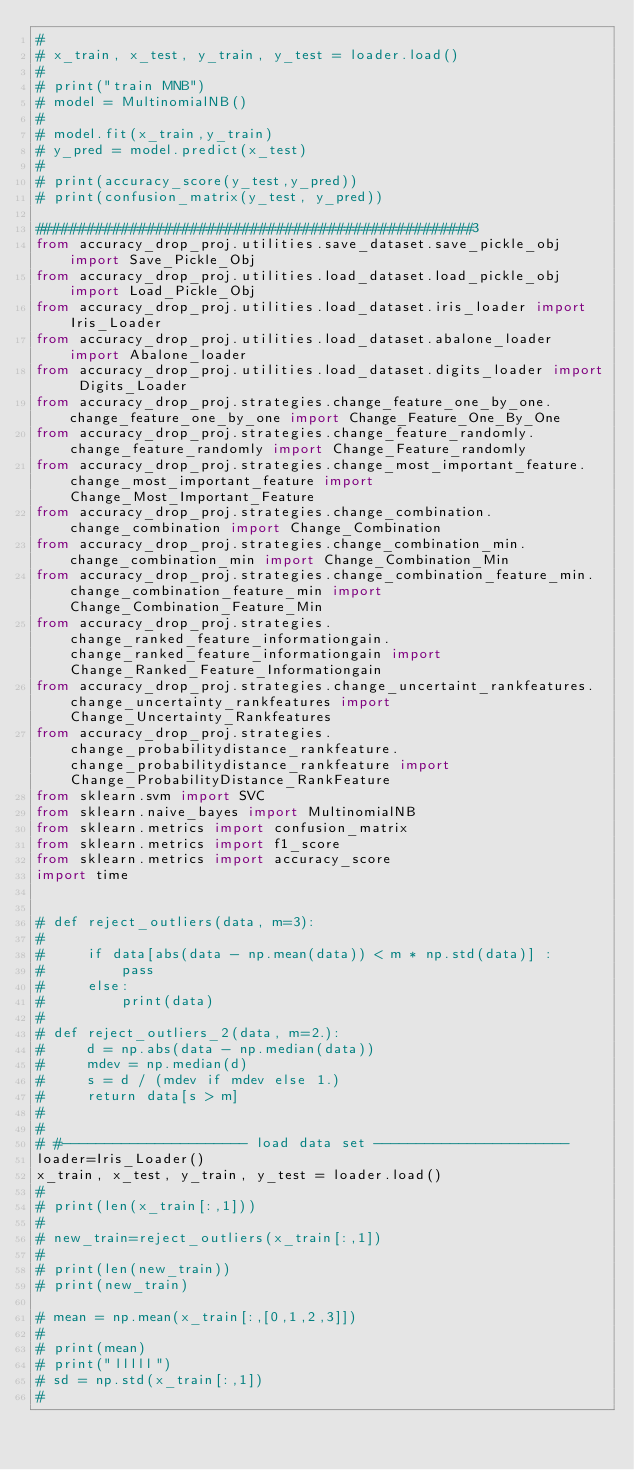<code> <loc_0><loc_0><loc_500><loc_500><_Python_>#
# x_train, x_test, y_train, y_test = loader.load()
#
# print("train MNB")
# model = MultinomialNB()
#
# model.fit(x_train,y_train)
# y_pred = model.predict(x_test)
#
# print(accuracy_score(y_test,y_pred))
# print(confusion_matrix(y_test, y_pred))

###################################################3
from accuracy_drop_proj.utilities.save_dataset.save_pickle_obj import Save_Pickle_Obj
from accuracy_drop_proj.utilities.load_dataset.load_pickle_obj import Load_Pickle_Obj
from accuracy_drop_proj.utilities.load_dataset.iris_loader import Iris_Loader
from accuracy_drop_proj.utilities.load_dataset.abalone_loader import Abalone_loader
from accuracy_drop_proj.utilities.load_dataset.digits_loader import Digits_Loader
from accuracy_drop_proj.strategies.change_feature_one_by_one.change_feature_one_by_one import Change_Feature_One_By_One
from accuracy_drop_proj.strategies.change_feature_randomly.change_feature_randomly import Change_Feature_randomly
from accuracy_drop_proj.strategies.change_most_important_feature.change_most_important_feature import Change_Most_Important_Feature
from accuracy_drop_proj.strategies.change_combination.change_combination import Change_Combination
from accuracy_drop_proj.strategies.change_combination_min.change_combination_min import Change_Combination_Min
from accuracy_drop_proj.strategies.change_combination_feature_min.change_combination_feature_min import Change_Combination_Feature_Min
from accuracy_drop_proj.strategies.change_ranked_feature_informationgain.change_ranked_feature_informationgain import Change_Ranked_Feature_Informationgain
from accuracy_drop_proj.strategies.change_uncertaint_rankfeatures.change_uncertainty_rankfeatures import Change_Uncertainty_Rankfeatures
from accuracy_drop_proj.strategies.change_probabilitydistance_rankfeature.change_probabilitydistance_rankfeature import Change_ProbabilityDistance_RankFeature
from sklearn.svm import SVC
from sklearn.naive_bayes import MultinomialNB
from sklearn.metrics import confusion_matrix
from sklearn.metrics import f1_score
from sklearn.metrics import accuracy_score
import time


# def reject_outliers(data, m=3):
#
#     if data[abs(data - np.mean(data)) < m * np.std(data)] :
#         pass
#     else:
#         print(data)
#
# def reject_outliers_2(data, m=2.):
#     d = np.abs(data - np.median(data))
#     mdev = np.median(d)
#     s = d / (mdev if mdev else 1.)
#     return data[s > m]
#
#
# #---------------------- load data set -----------------------
loader=Iris_Loader()
x_train, x_test, y_train, y_test = loader.load()
#
# print(len(x_train[:,1]))
#
# new_train=reject_outliers(x_train[:,1])
#
# print(len(new_train))
# print(new_train)

# mean = np.mean(x_train[:,[0,1,2,3]])
#
# print(mean)
# print("lllll")
# sd = np.std(x_train[:,1])
#</code> 